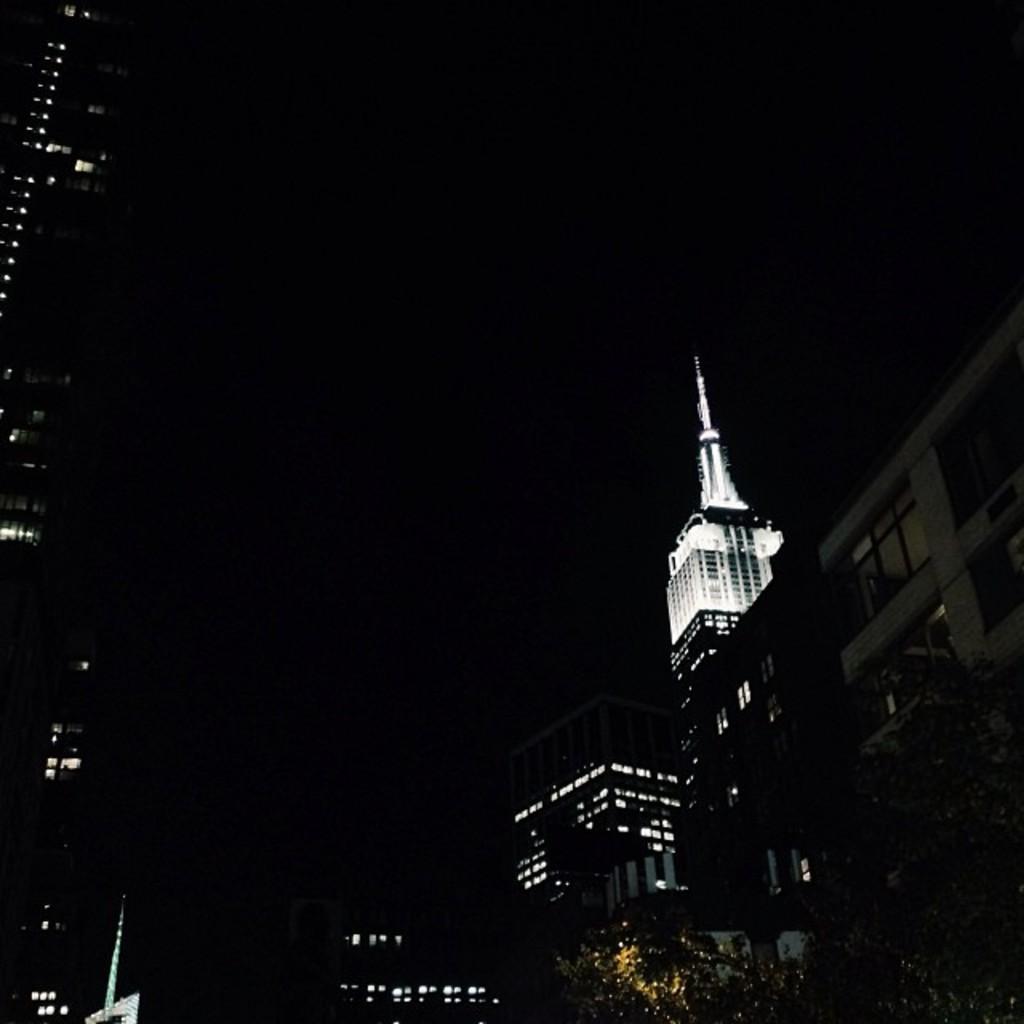In one or two sentences, can you explain what this image depicts? In the image there are buildings on either side with lights in it, this is clicked at night time. 